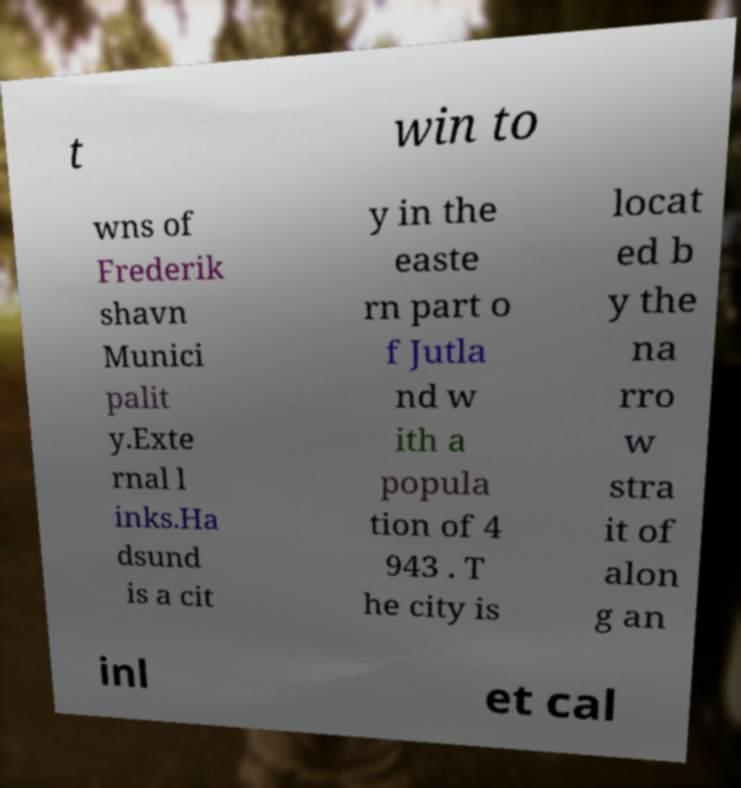For documentation purposes, I need the text within this image transcribed. Could you provide that? t win to wns of Frederik shavn Munici palit y.Exte rnal l inks.Ha dsund is a cit y in the easte rn part o f Jutla nd w ith a popula tion of 4 943 . T he city is locat ed b y the na rro w stra it of alon g an inl et cal 